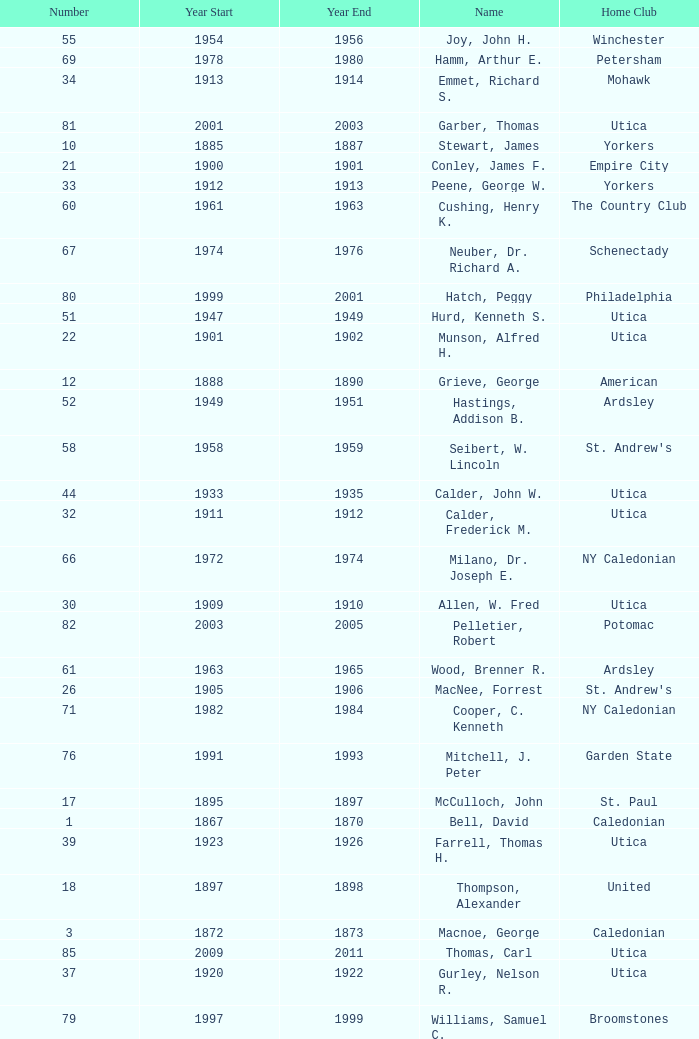Which Year Start has a Number of 28? 1907.0. 